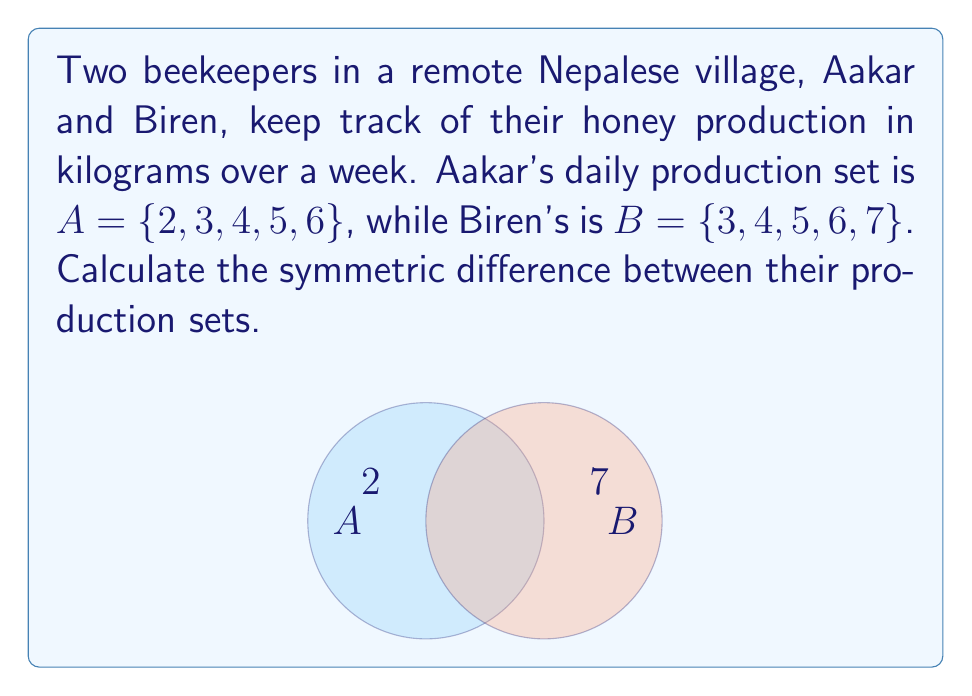Can you solve this math problem? To find the symmetric difference between sets A and B, we need to follow these steps:

1) Recall that the symmetric difference of two sets A and B, denoted as A Δ B, is defined as:

   $$ A \triangle B = (A \setminus B) \cup (B \setminus A) $$

2) First, let's find A \ B (elements in A but not in B):
   A \ B = {2}

3) Next, let's find B \ A (elements in B but not in A):
   B \ A = {7}

4) Now, we unite these two sets:
   (A \ B) ∪ (B \ A) = {2} ∪ {7} = {2, 7}

Therefore, the symmetric difference A Δ B = {2, 7}.

This means that 2 kg and 7 kg are the honey production amounts that are unique to either Aakar or Biren, but not common to both.
Answer: {2, 7} 